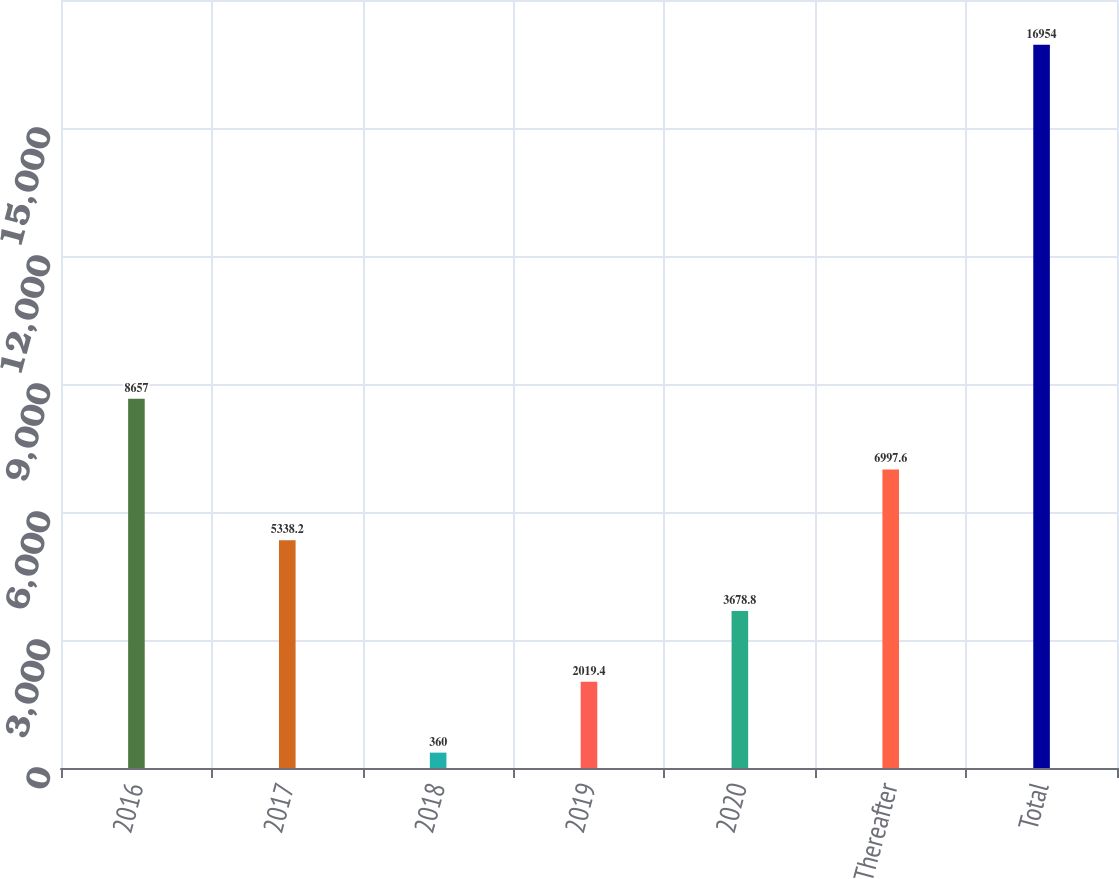Convert chart to OTSL. <chart><loc_0><loc_0><loc_500><loc_500><bar_chart><fcel>2016<fcel>2017<fcel>2018<fcel>2019<fcel>2020<fcel>Thereafter<fcel>Total<nl><fcel>8657<fcel>5338.2<fcel>360<fcel>2019.4<fcel>3678.8<fcel>6997.6<fcel>16954<nl></chart> 